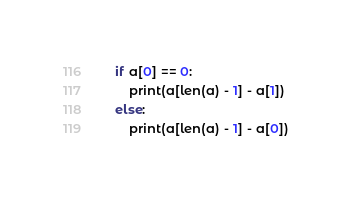Convert code to text. <code><loc_0><loc_0><loc_500><loc_500><_Python_>if a[0] == 0:
    print(a[len(a) - 1] - a[1])
else:
    print(a[len(a) - 1] - a[0])</code> 